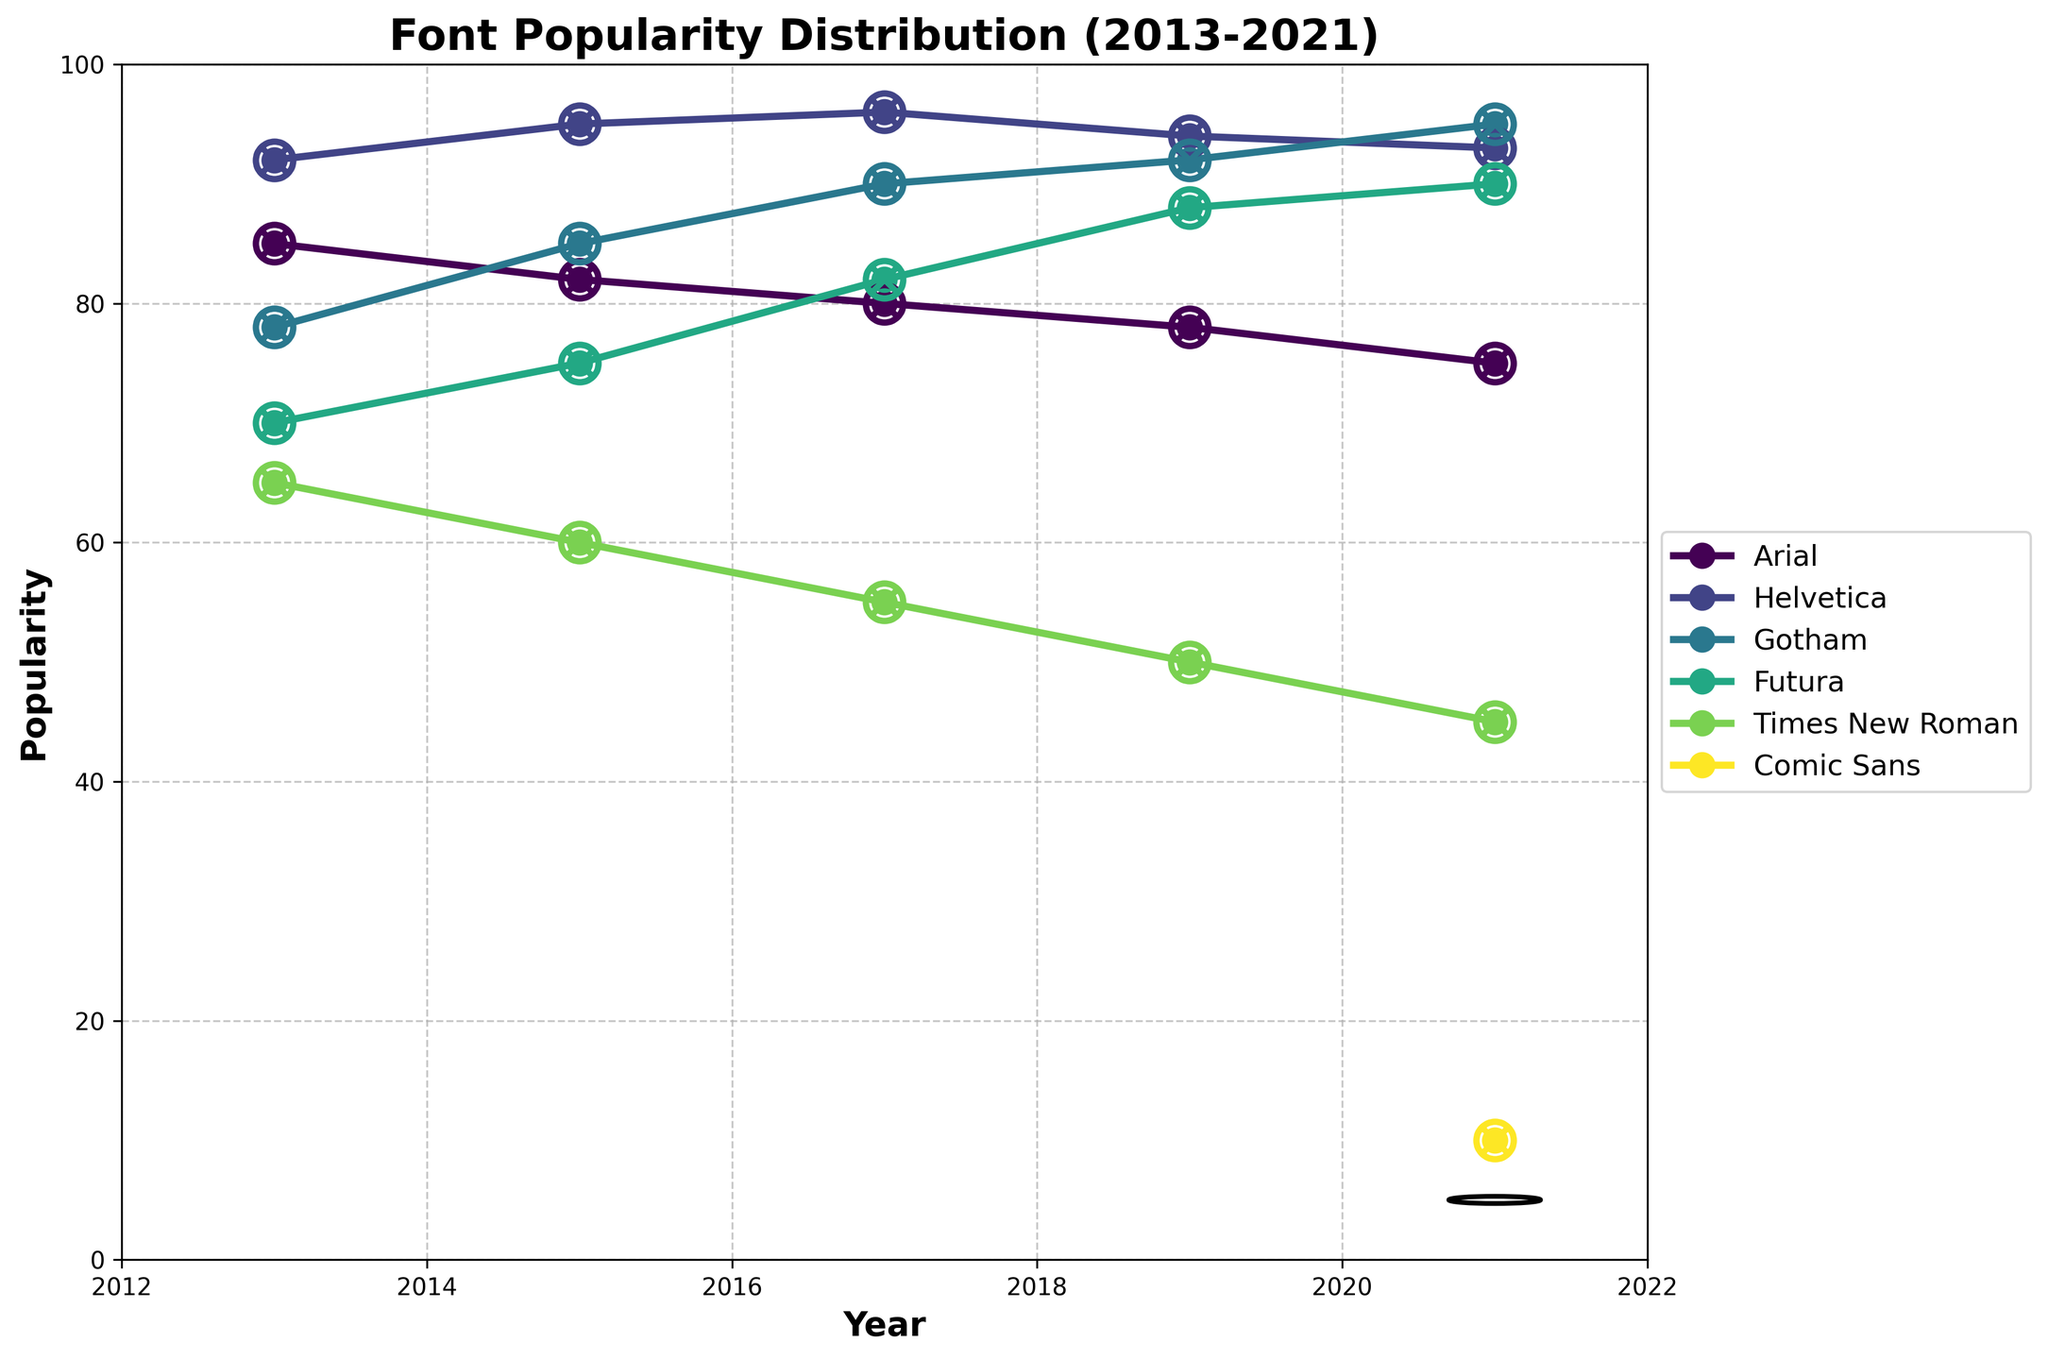What is the title of the figure? The title of the figure is prominent at the top of the plot and is written in bold.
Answer: Font Popularity Distribution (2013-2021) Which font has the highest popularity in 2017? By looking at the data points for 2017 on the x-axis, we can see that Helvetica has the highest popularity.
Answer: Helvetica How has the popularity of Times New Roman changed from 2013 to 2021? Start at the 2013 point of Times New Roman, which is at 65, and observe the points up to 2021, which is 45. The popularity has gradually decreased each year.
Answer: Decreased Which year shows the introduction of Comic Sans in the dataset? The figure's x-axis covers years 2013 to 2021, and Comic Sans appears only in 2021.
Answer: 2021 How many fonts are represented in the figure for the year 2021? By counting the unique data points for the year 2021, which is marked on the x-axis, we find that there are six unique fonts.
Answer: Six What is the popularity difference between Gotham and Futura in 2019? Looking at the y-values for 2019 for Gotham (92) and Futura (88), the difference can be calculated as 92 - 88.
Answer: 4 Which font shows a steady increase in popularity over the years? By following the trend lines for each font, Helvetica shows a consistent increase in its popularity from 2013 to 2021.
Answer: Helvetica How does the popularity of Arial in 2015 compare to its popularity in 2021? Viewing the y-values for Arial in the years 2015 (82) and 2021 (75), it has decreased from 82 to 75.
Answer: Decreased What is the visual marker used for highlighting specific data points in the figure? The figure uses cat paw prints $\bigotimes$ to mark specific data points for each font on the plot.
Answer: Cat paw prints Is there any font whose popularity remained constant throughout the years? By observing the trend lines, all fonts experience some fluctuations; none remained constant in popularity.
Answer: No 